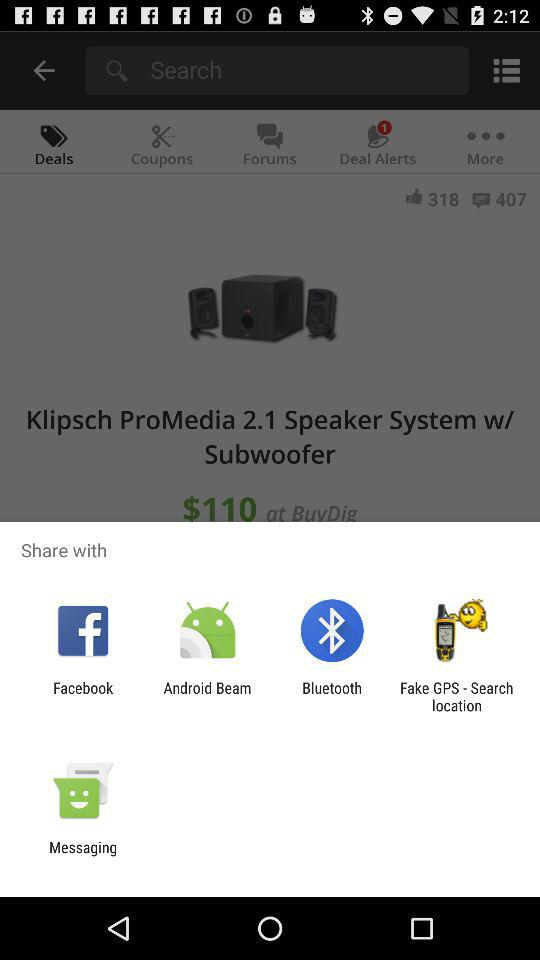What are the sharing options available? The sharing options are "Facebook", "Android Beam", "Bluetooth", "Fake GPS - Search location" and "Messaging". 